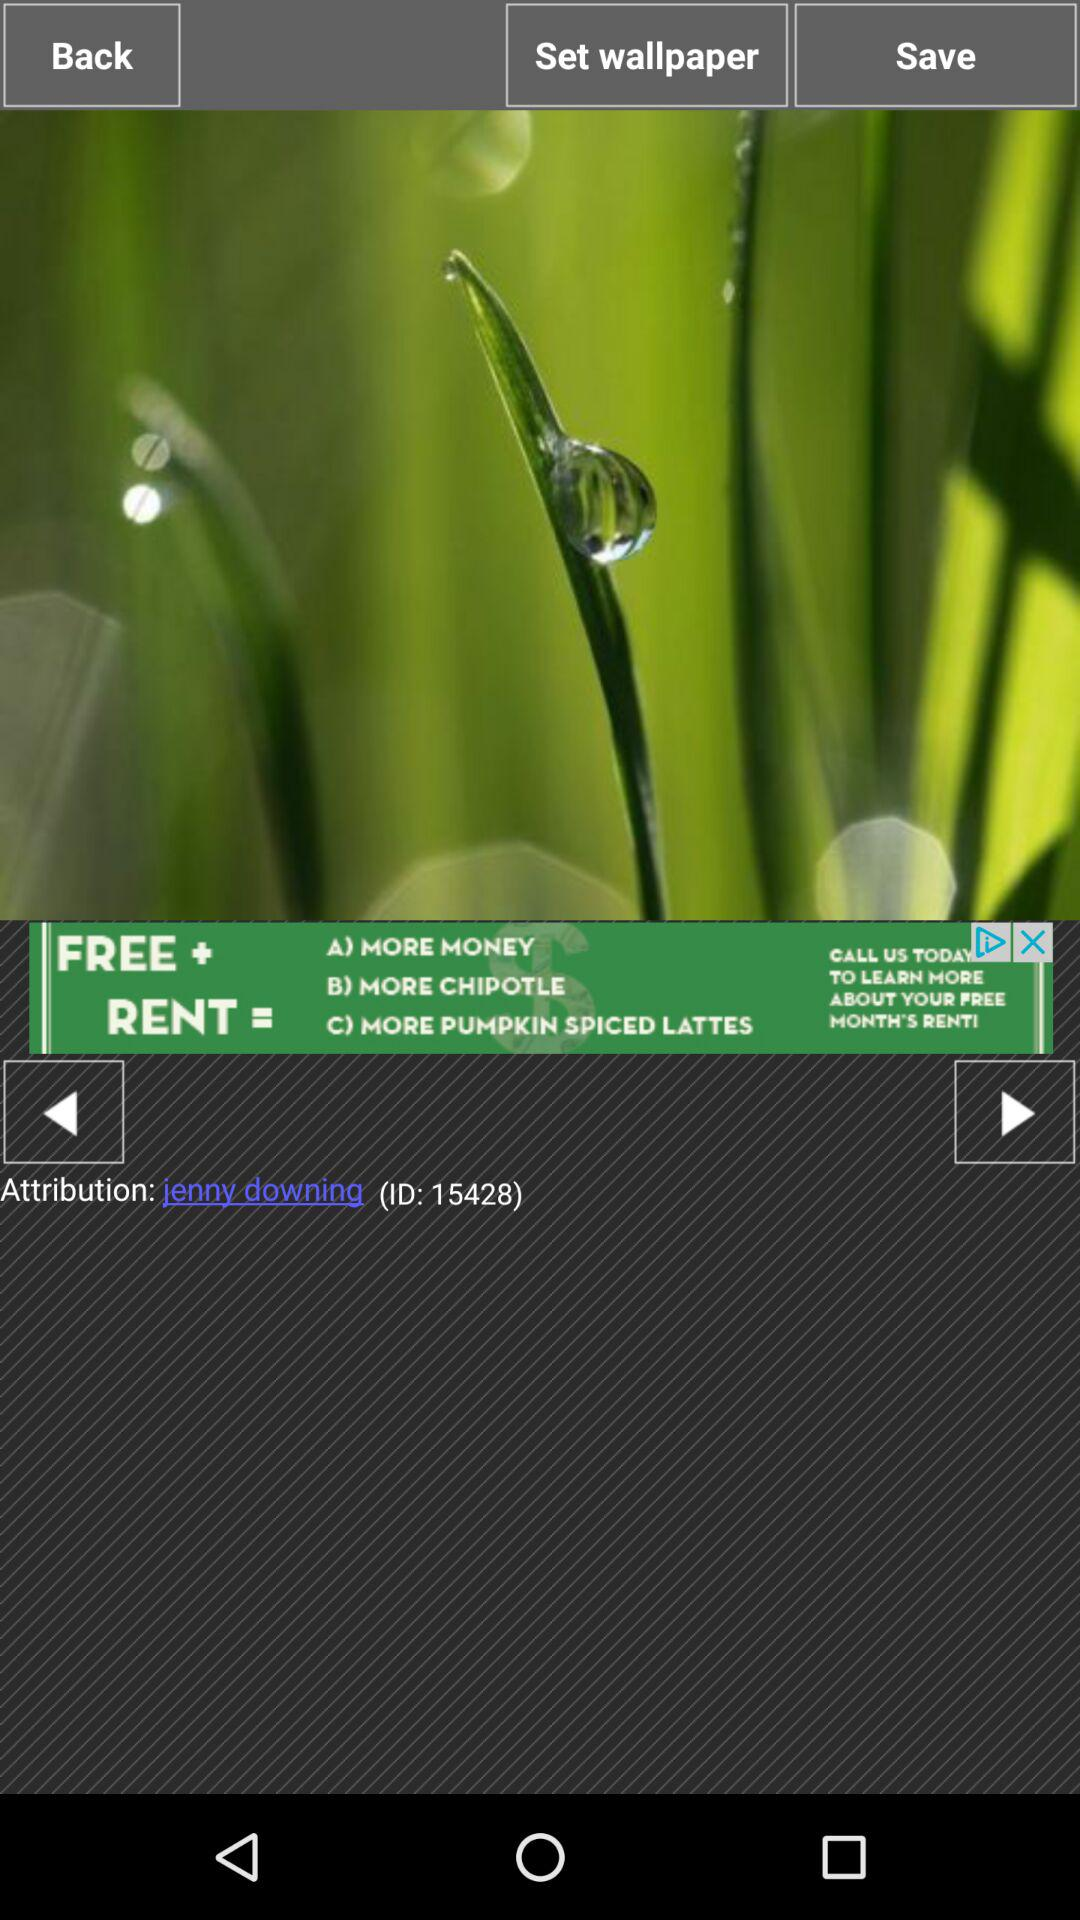What is the ID number? The ID number is 15428. 